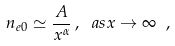Convert formula to latex. <formula><loc_0><loc_0><loc_500><loc_500>n _ { e 0 } \simeq \frac { A } { x ^ { \alpha } } \, , \ a s x \rightarrow \infty \ ,</formula> 